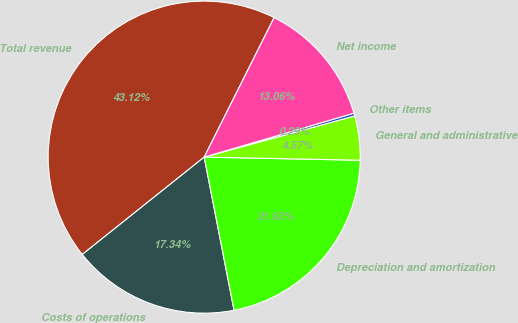<chart> <loc_0><loc_0><loc_500><loc_500><pie_chart><fcel>Total revenue<fcel>Costs of operations<fcel>Depreciation and amortization<fcel>General and administrative<fcel>Other items<fcel>Net income<nl><fcel>43.12%<fcel>17.34%<fcel>21.62%<fcel>4.57%<fcel>0.29%<fcel>13.06%<nl></chart> 